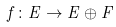<formula> <loc_0><loc_0><loc_500><loc_500>f \colon E \to E \oplus F</formula> 